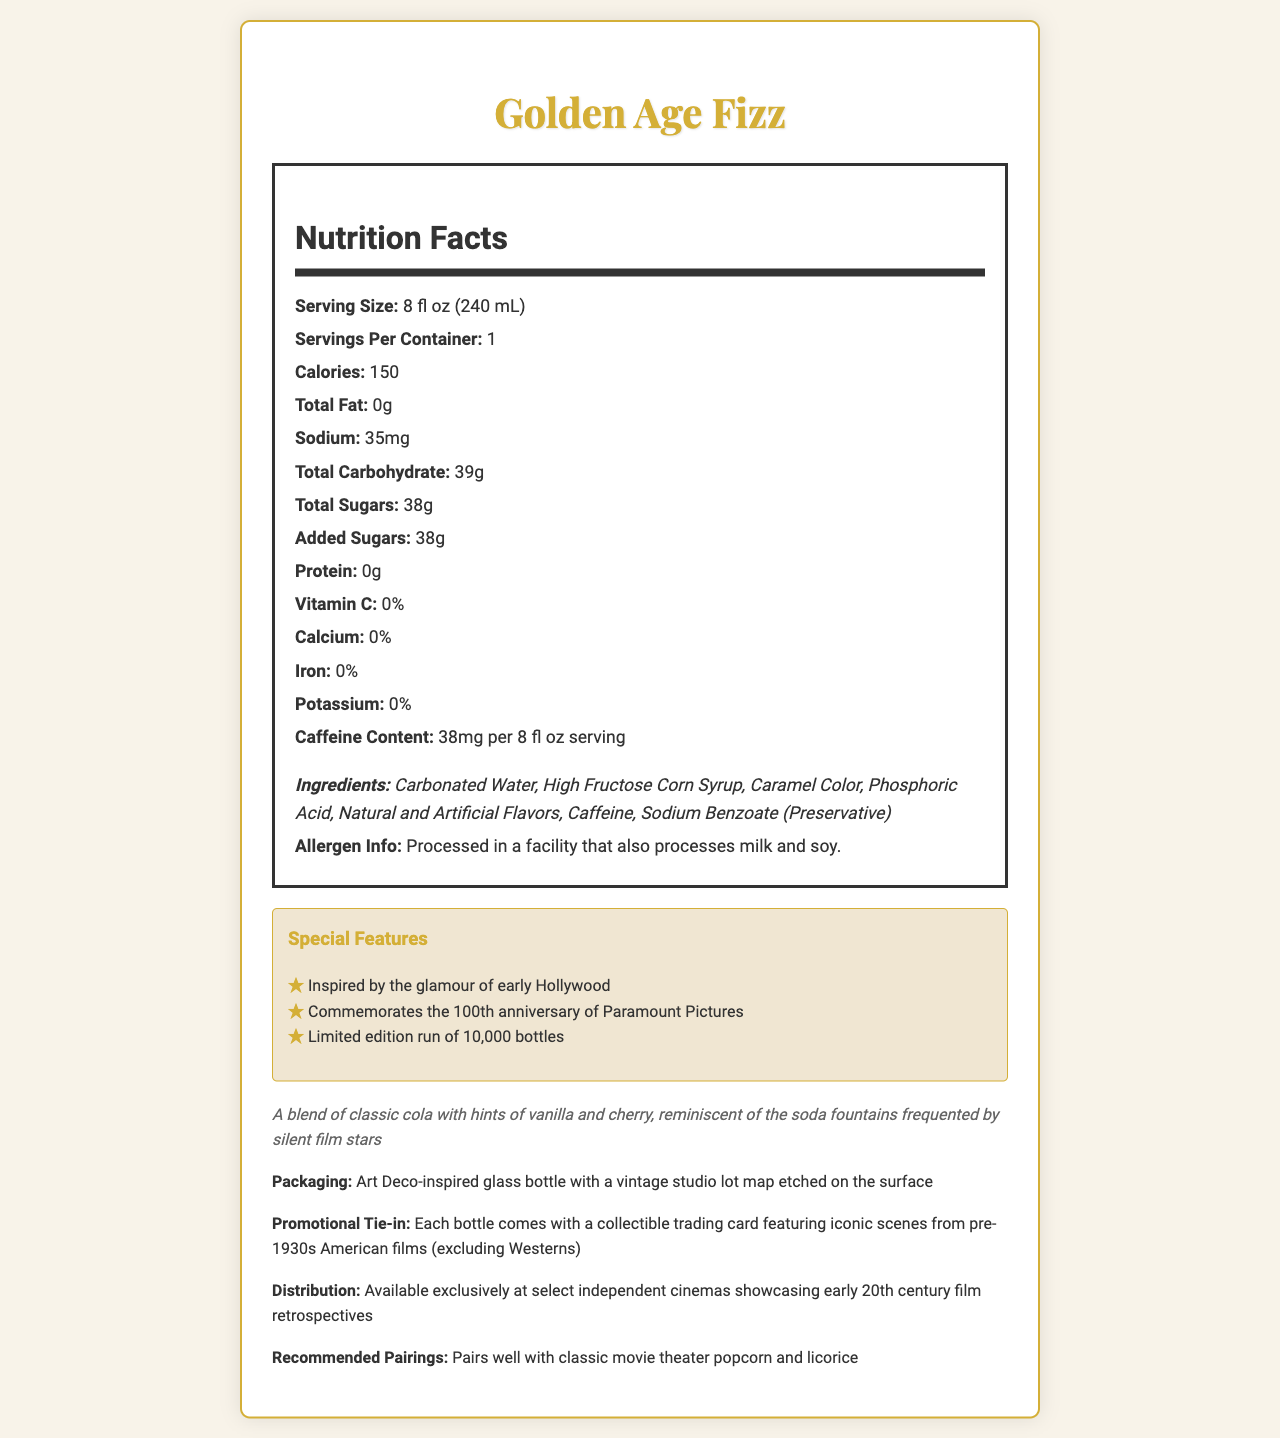what is the serving size of the Golden Age Fizz? The Nutrition Facts label lists the serving size as 8 fl oz (240 mL).
Answer: 8 fl oz (240 mL) how many calories are in one serving of Golden Age Fizz? The Nutrition Facts label states that there are 150 calories per serving.
Answer: 150 what is the amount of added sugars in the Golden Age Fizz? The Nutrition Facts label indicates that there are 38 grams of added sugars.
Answer: 38g list the ingredients of the Golden Age Fizz. The ingredients are listed in the Nutrition Facts label under the "Ingredients" section.
Answer: Carbonated Water, High Fructose Corn Syrup, Caramel Color, Phosphoric Acid, Natural and Artificial Flavors, Caffeine, Sodium Benzoate (Preservative) is there any protein in the Golden Age Fizz? The Nutrition Facts label shows 0g of protein.
Answer: No which Hollywood studio is commemorated by Golden Age Fizz? A. Warner Bros. B. Paramount Pictures C. Universal Studios D. MGM The "Special Features" section mentions that it commemorates the 100th anniversary of Paramount Pictures.
Answer: B how much caffeine is in each serving of Golden Age Fizz? A. 20mg B. 38mg C. 45mg D. 50mg The Nutrition Facts label states that there are 38mg of caffeine per 8 fl oz serving.
Answer: B is Golden Age Fizz recommended to pair with film screenings? (Yes/No) The "Distribution" section mentions the beverage is available at select independent cinemas showcasing early 20th century film retrospectives.
Answer: Yes are there any vitamins or minerals in Golden Age Fizz? The Nutrition Facts label shows 0% for Vitamin C, Calcium, Iron, and Potassium.
Answer: No what type of collectible item comes with each bottle of Golden Age Fizz? The "Promotional Tie-in" section specifies that each bottle comes with a collectible trading card featuring scenes from pre-1930s American films (except Westerns).
Answer: A collectible trading card featuring iconic scenes from pre-1930s American films (excluding Westerns) how does the packaging of the Golden Age Fizz contribute to its nostalgic appeal? The "Packaging" section describes the bottle as an Art Deco-inspired glass bottle with a vintage studio lot map etched on it, reflecting the early Hollywood aesthetic.
Answer: Art Deco-inspired glass bottle with a vintage studio lot map etched on the surface summarize the main idea of the Nutrition Facts label for the Golden Age Fizz. The document provides nutritional information, ingredients, special features, packaging details, and promotional aspects of the Golden Age Fizz soda.
Answer: The Golden Age Fizz is a limited-edition soda inspired by early Hollywood, celebrating 100 years of Paramount Pictures. It has 150 calories, 38 grams of sugars, and 38mg of caffeine per 8 fl oz serving. The ingredients include High Fructose Corn Syrup and caramel color, and it is packaged in an Art Deco bottle with a promotional tie-in of collectible trading cards. who is the target audience for the Golden Age Fizz? The document specifies its sale locations and the era it commemorates but doesn't explicitly state the target demographic beyond those interested in the early 20th century cinema.
Answer: Not enough information 